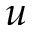<formula> <loc_0><loc_0><loc_500><loc_500>u</formula> 